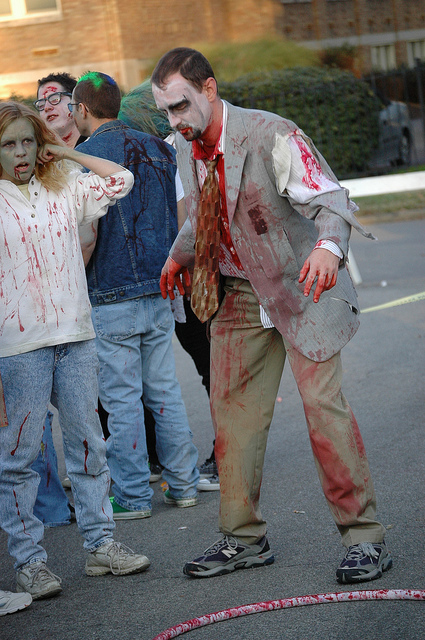How many people are there? There are four individuals visible in this image, all dressed up to resemble zombies, complete with makeup and blood-stained clothing, likely participating in a themed event or festivity. 